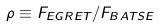<formula> <loc_0><loc_0><loc_500><loc_500>\rho \equiv F _ { E G R E T } / F _ { B A T S E }</formula> 